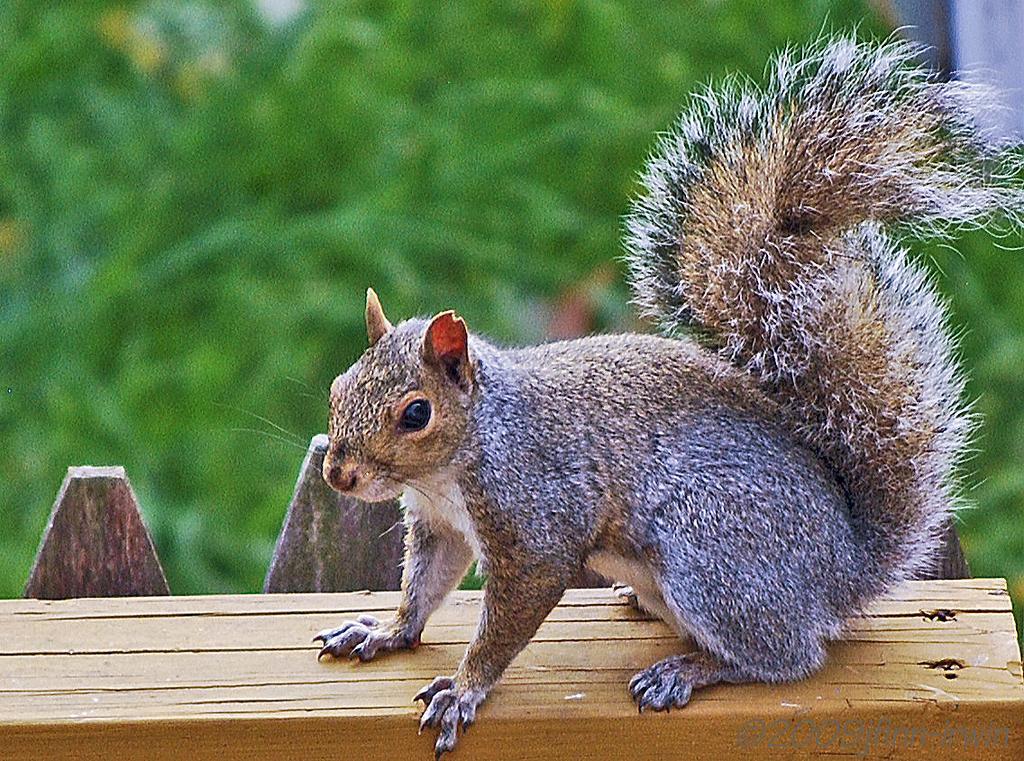Please provide a concise description of this image. This is the picture of a squirrel which is on the wooden floor and behind there are some plants. 